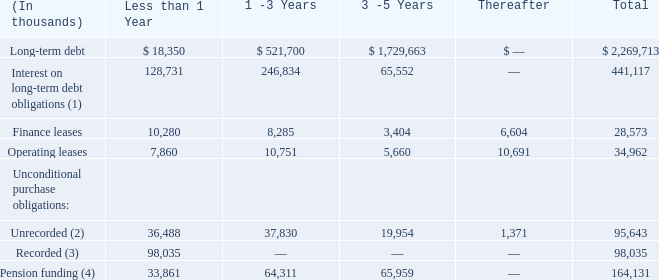Contractual Obligations As of December 31, 2019, our contractual obligations were as follows:
(1) Interest on long-term debt includes amounts due on fixed and variable rate debt. As the rates on our variable debt are subject to change, the rates in effect at December 31, 2019 were used in determining our future interest obligations. Expected settlements of interest rate swap agreements were estimated using yield curves in effect at December 31, 2019.
(2) Unrecorded purchase obligations include binding commitments for future capital expenditures and service and maintenance agreements to support various computer hardware and software applications and certain equipment. If we terminate any of the contracts prior to their expiration date, we would be liable for minimum commitment payments as defined by the contractual terms of the contracts.
(3) Recorded obligations include amounts in accounts payable and accrued expenses for external goods and services received as of December 31, 2019 and expected to be settled in cash.
(4) Expected contributions to our pension and post-retirement benefit plans for the next 5 years. Actual contributions could differ from these estimates and extend beyond 5 years.
Defined Benefit Pension Plans As required, we contribute to qualified defined pension plans and non-qualified supplemental retirement plans (collectively the “Pension Plans”) and other post-retirement benefit plans, which provide retirement benefits to certain eligible employees. Contributions are intended to provide for benefits attributed to service to date. Our funding policy is to contribute annually an actuarially determined amount consistent with applicable federal income tax regulations.
The cost to maintain our Pension Plans and future funding requirements are affected by several factors including the expected return on investment of the assets held by the Pension Plans, changes in the discount rate used to calculate pension expense and the amortization of unrecognized gains and losses. Returns generated on the Pension Plans assets have historically funded a significant portion of the benefits paid under the Pension Plans. We used a weighted-average expected long-term rate of return of 6.97% and 7.03% in 2019 and 2018, respectively. As of January 1, 2020, we estimate the longterm rate of return of Plan assets will be 6.25%. The Pension Plans invest in marketable equity securities which are exposed to changes in the financial markets. If the financial markets experience a downturn and returns fall below our estimate, we could be required to make material contributions to the Pension Plans, which could adversely affect our cash flows from operations.
Net pension and post-retirement costs were $11.5 million, $5.6 million and $3.8 million for the years ended December 31, 2019, 2018 and 2017, respectively. We contributed $27.5 million, $26.2 million and $12.5 million in 2019, 2018 and 2017, respectively to our Pension Plans. For our other post-retirement plans, we contributed $8.5 million, $9.7 million and $6.5 million in 2019, 2018 and 2017, respectively. In 2020, we expect to make contributions totaling approximately $25.0 million to our Pension Plans and $8.9 million to our other post-retirement benefit plans. Our contribution amounts meet the minimum funding requirements as set forth in employee benefit and tax laws. See Note 11 to the consolidated financial statements for a more detailed discussion regarding our pension and other post-retirement plans.
On which debt is the interest on long-term debt is charged? Interest on long-term debt includes amounts due on fixed and variable rate debt. What was the total long term debt?
Answer scale should be: thousand. $ 2,269,713. What was the total finance leases?
Answer scale should be: thousand. 28,573. What was the change between the long-term debt 1-3 years and 3-5 years?
Answer scale should be: thousand. 1,729,663 - 521,700
Answer: 1207963. What was the change between the finance leases from 3-5 years and thereafter?
Answer scale should be: thousand. 6,604 - 3,404
Answer: 3200. What was the change in pension funding between 1-3 years and 3-5 years?
Answer scale should be: thousand. 65,959 - 64,311
Answer: 1648. 